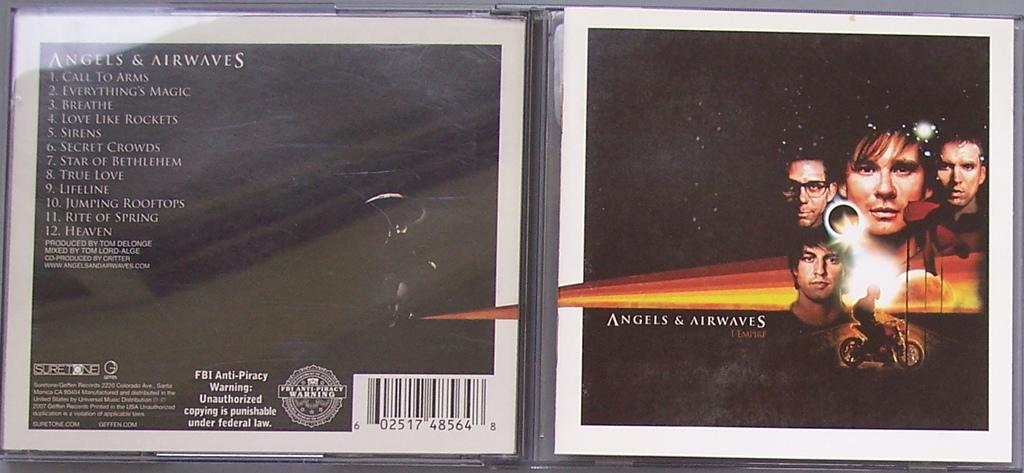<image>
Share a concise interpretation of the image provided. The I-Empire cd of the music group Angels & Airwaves 